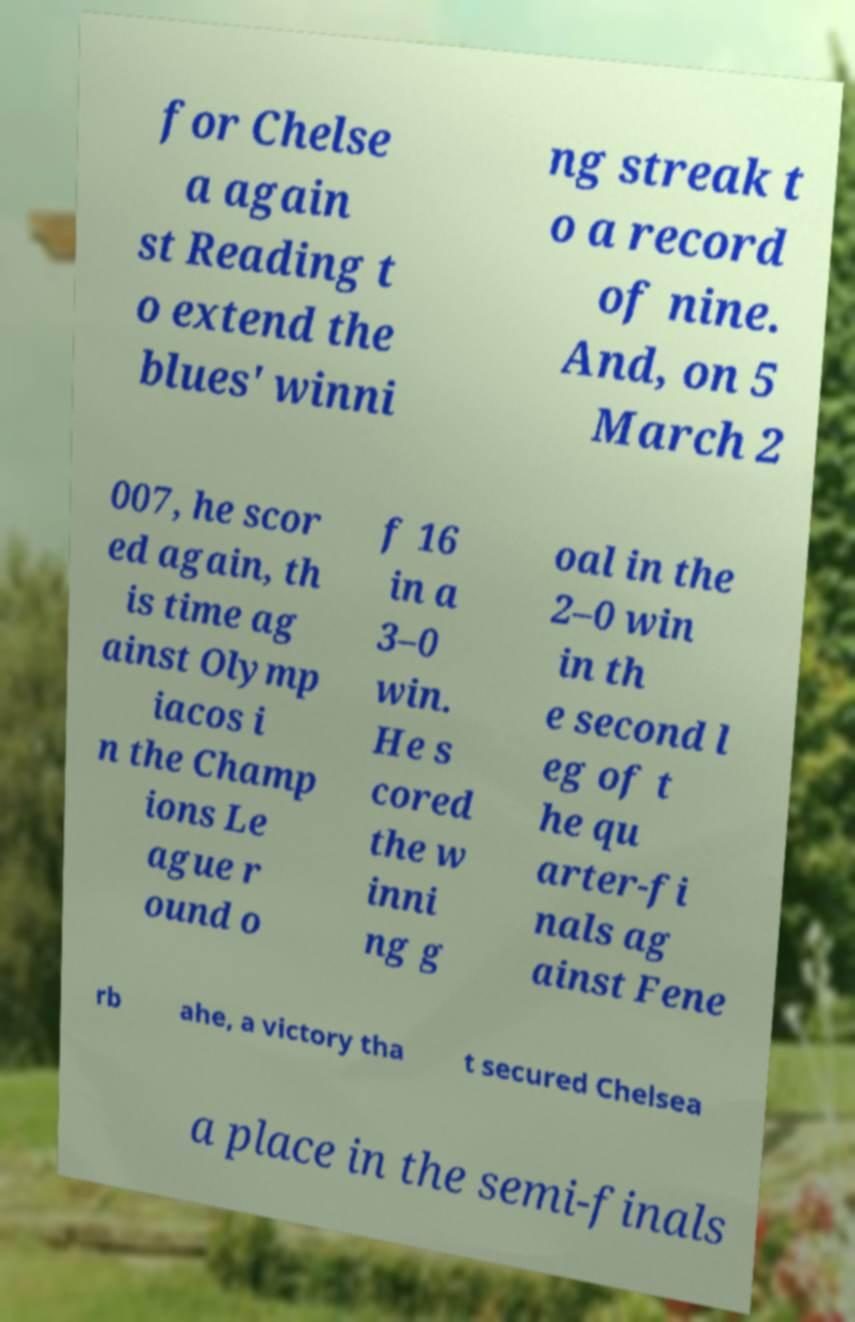Please read and relay the text visible in this image. What does it say? for Chelse a again st Reading t o extend the blues' winni ng streak t o a record of nine. And, on 5 March 2 007, he scor ed again, th is time ag ainst Olymp iacos i n the Champ ions Le ague r ound o f 16 in a 3–0 win. He s cored the w inni ng g oal in the 2–0 win in th e second l eg of t he qu arter-fi nals ag ainst Fene rb ahe, a victory tha t secured Chelsea a place in the semi-finals 